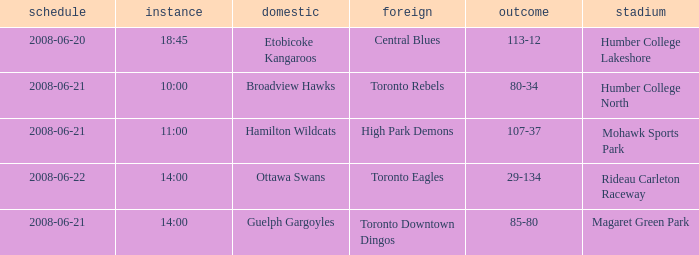What is the Time with a Score that is 80-34? 10:00. 